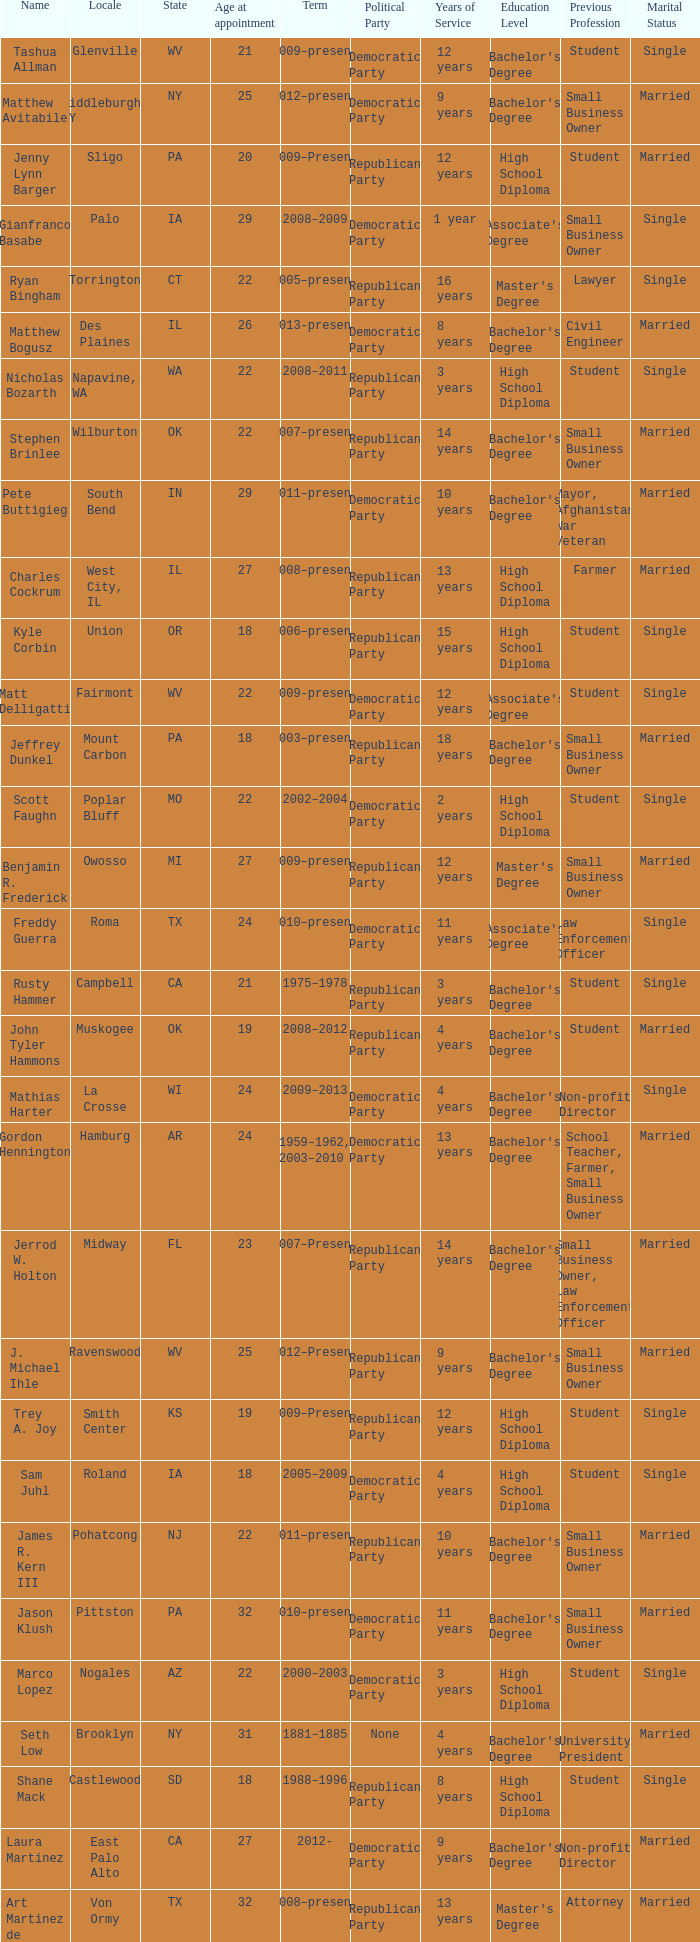What is the name of the holland locale Philip A. Tanis. 